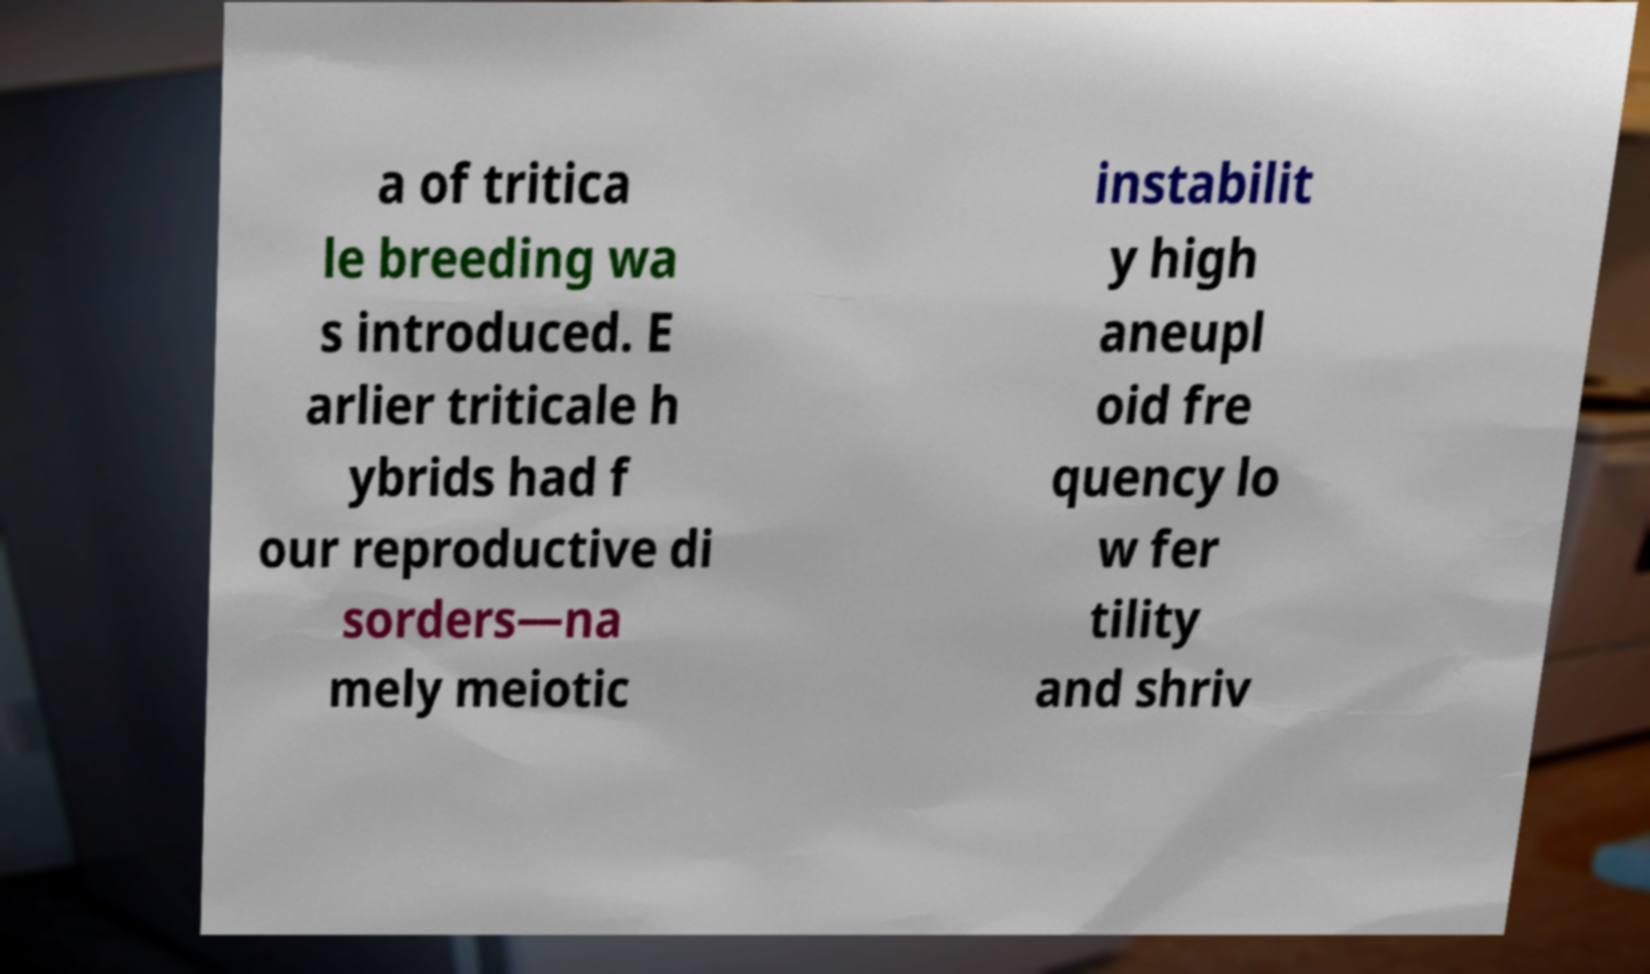Please read and relay the text visible in this image. What does it say? a of tritica le breeding wa s introduced. E arlier triticale h ybrids had f our reproductive di sorders—na mely meiotic instabilit y high aneupl oid fre quency lo w fer tility and shriv 